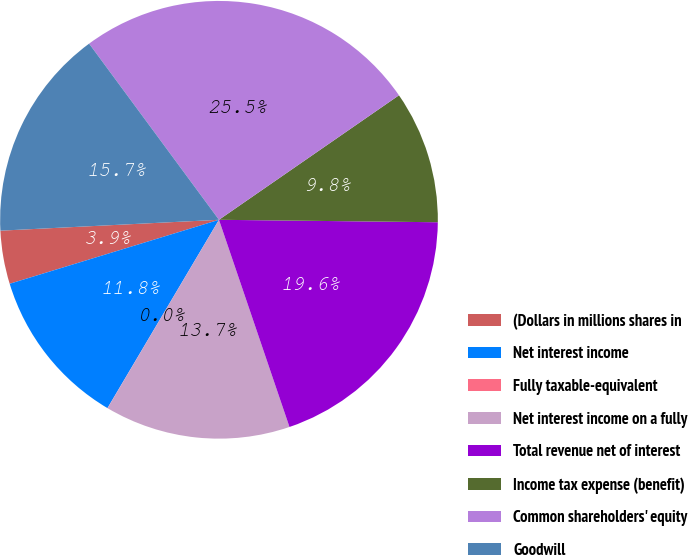Convert chart. <chart><loc_0><loc_0><loc_500><loc_500><pie_chart><fcel>(Dollars in millions shares in<fcel>Net interest income<fcel>Fully taxable-equivalent<fcel>Net interest income on a fully<fcel>Total revenue net of interest<fcel>Income tax expense (benefit)<fcel>Common shareholders' equity<fcel>Goodwill<nl><fcel>3.93%<fcel>11.77%<fcel>0.01%<fcel>13.72%<fcel>19.6%<fcel>9.81%<fcel>25.48%<fcel>15.68%<nl></chart> 